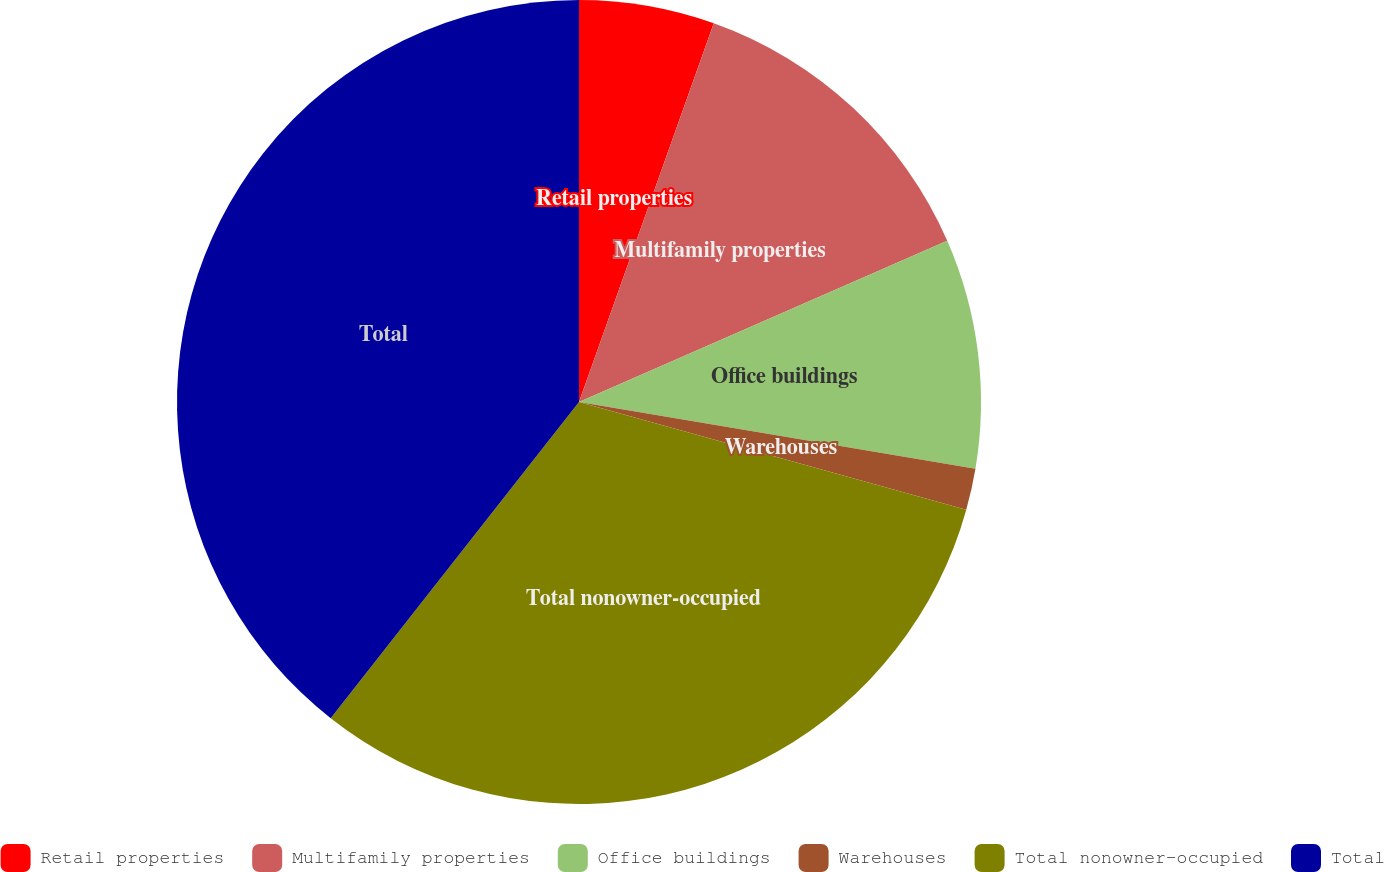Convert chart to OTSL. <chart><loc_0><loc_0><loc_500><loc_500><pie_chart><fcel>Retail properties<fcel>Multifamily properties<fcel>Office buildings<fcel>Warehouses<fcel>Total nonowner-occupied<fcel>Total<nl><fcel>5.44%<fcel>12.99%<fcel>9.22%<fcel>1.67%<fcel>31.27%<fcel>39.4%<nl></chart> 